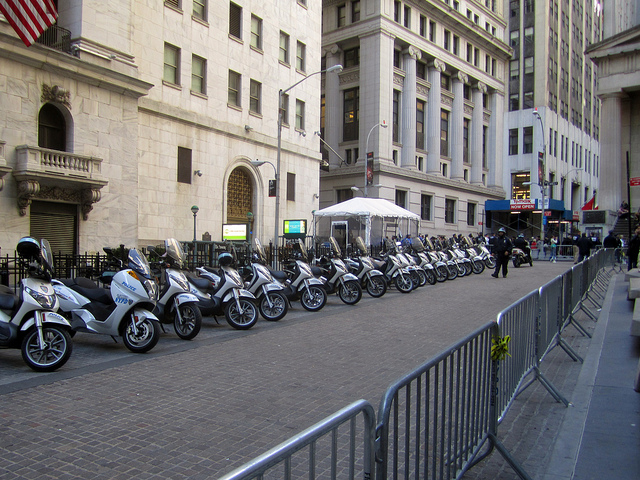<image>Where the woman be walking too? It is impossible to determine where the woman is walking to. Where the woman be walking too? I don't know where the woman is walking to. It could be work, store, or restroom. 